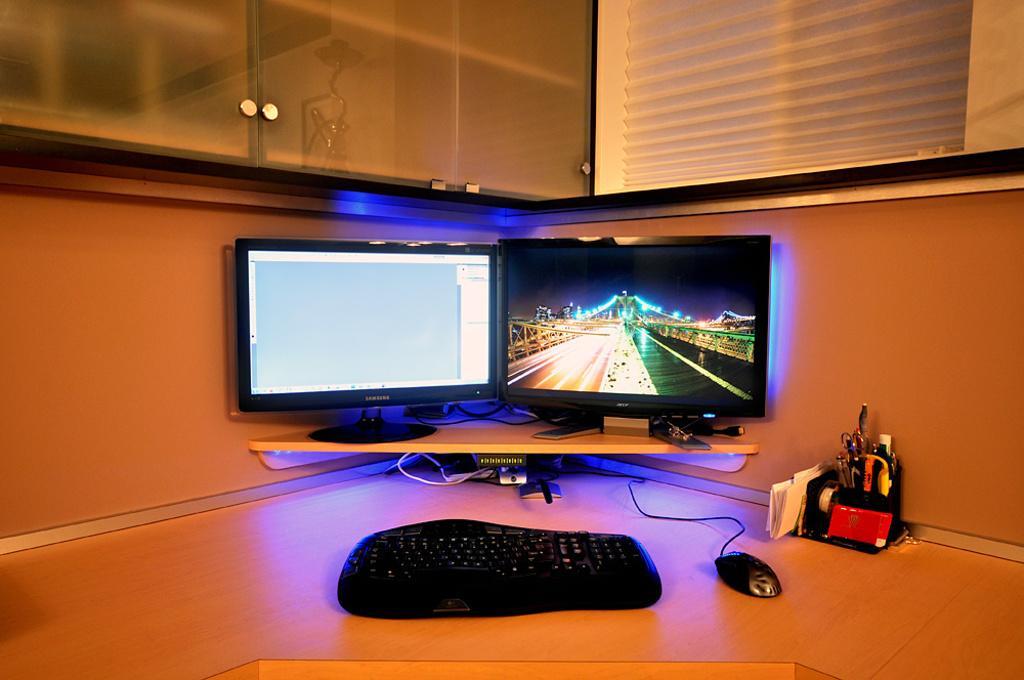How would you summarize this image in a sentence or two? There are two monitors,keyboard,mouse and few other articles on a desk at a corner of a room. 